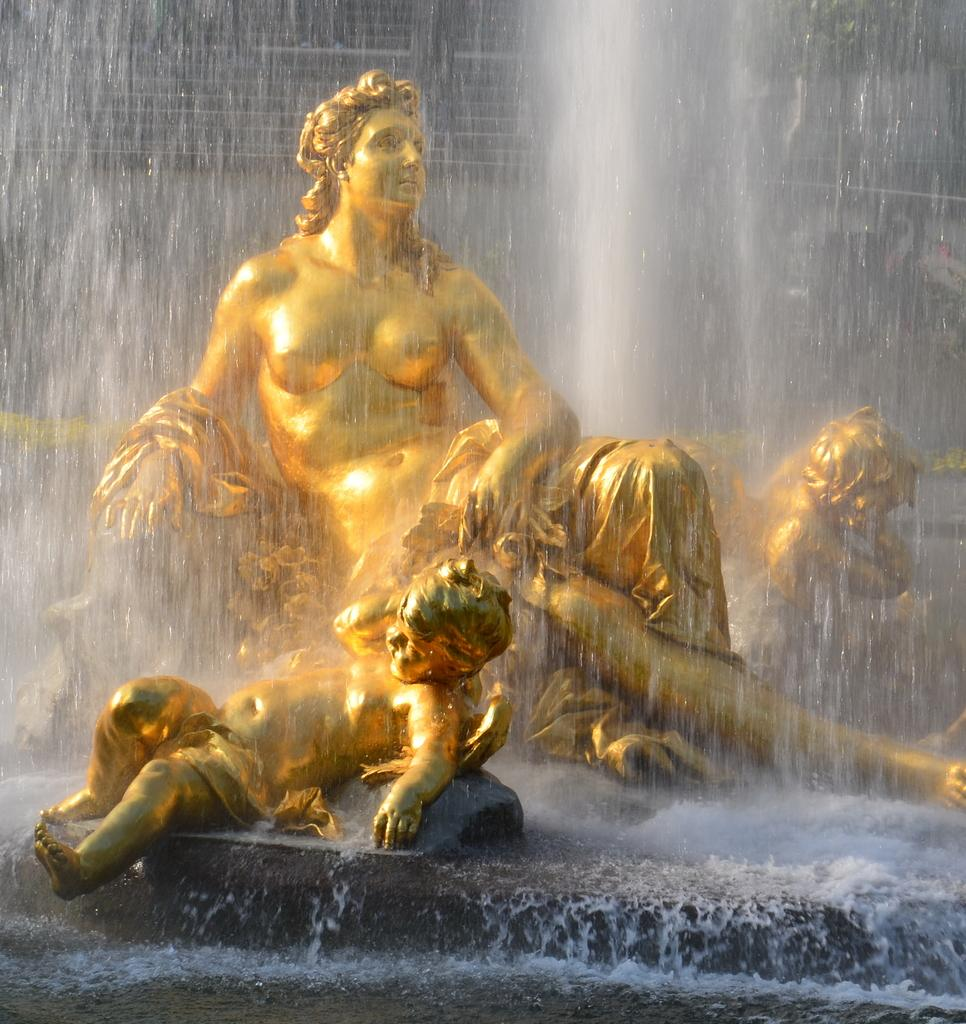What is visible in the image? There is water and gold color statues of people visible in the image. Can you describe the statues in the image? The statues are gold in color and represent people. What is the primary element in the image? Water is the primary element visible in the image. How many tomatoes can be seen floating in the water in the image? There are no tomatoes present in the image; it features water and gold color statues of people. What type of creature is swimming alongside the statues in the image? There is no creature present in the image; it only features water and gold color statues of people. 